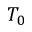<formula> <loc_0><loc_0><loc_500><loc_500>T _ { 0 }</formula> 